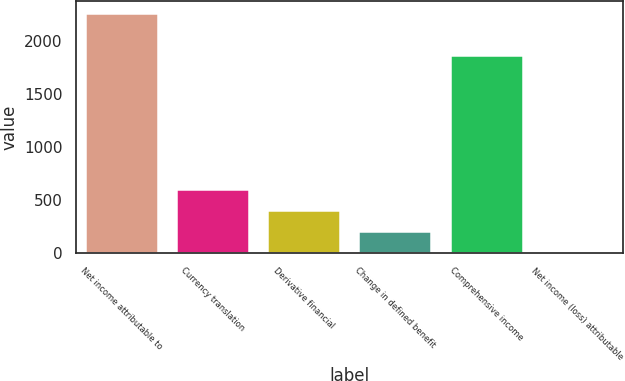Convert chart to OTSL. <chart><loc_0><loc_0><loc_500><loc_500><bar_chart><fcel>Net income attributable to<fcel>Currency translation<fcel>Derivative financial<fcel>Change in defined benefit<fcel>Comprehensive income<fcel>Net income (loss) attributable<nl><fcel>2268<fcel>604.5<fcel>406<fcel>207.5<fcel>1871<fcel>9<nl></chart> 